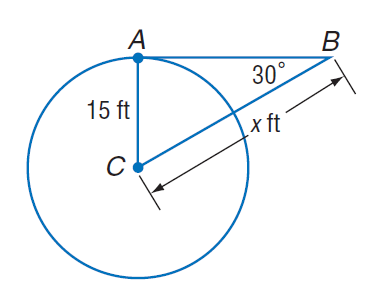Question: Find x. Assume that segments that appear to be tangent are tangent.
Choices:
A. 15
B. 20
C. 15 \sqrt { 3 }
D. 30
Answer with the letter. Answer: D 